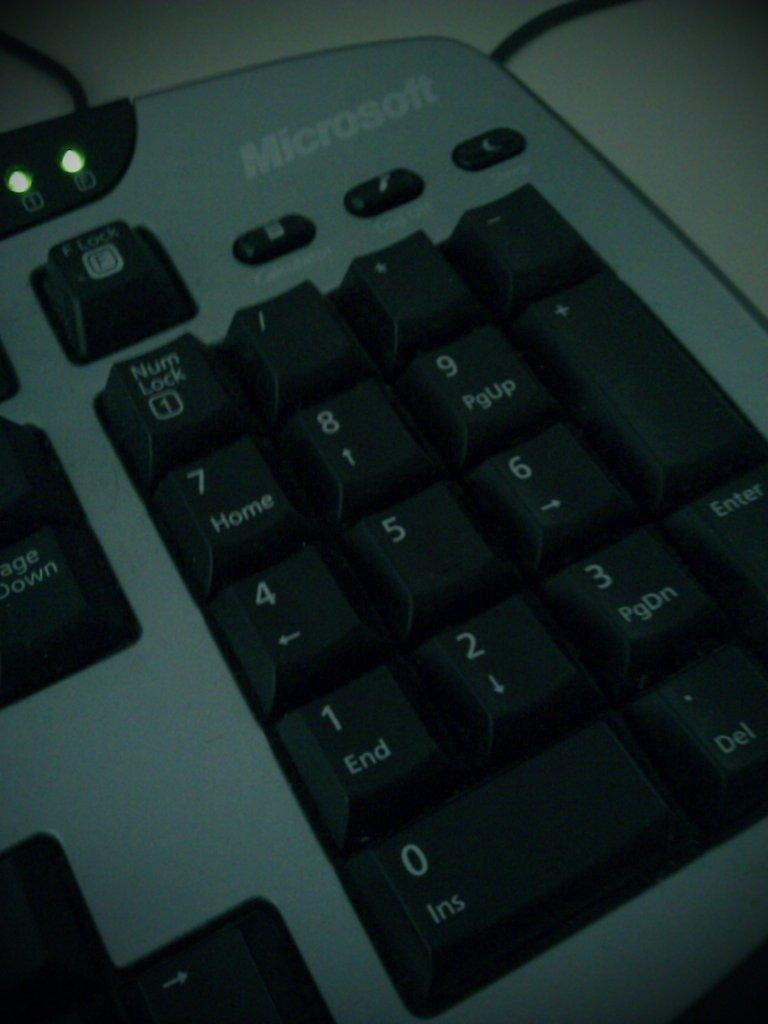<image>
Summarize the visual content of the image. The number keypad on a Microsoft black and gray keyboard. 